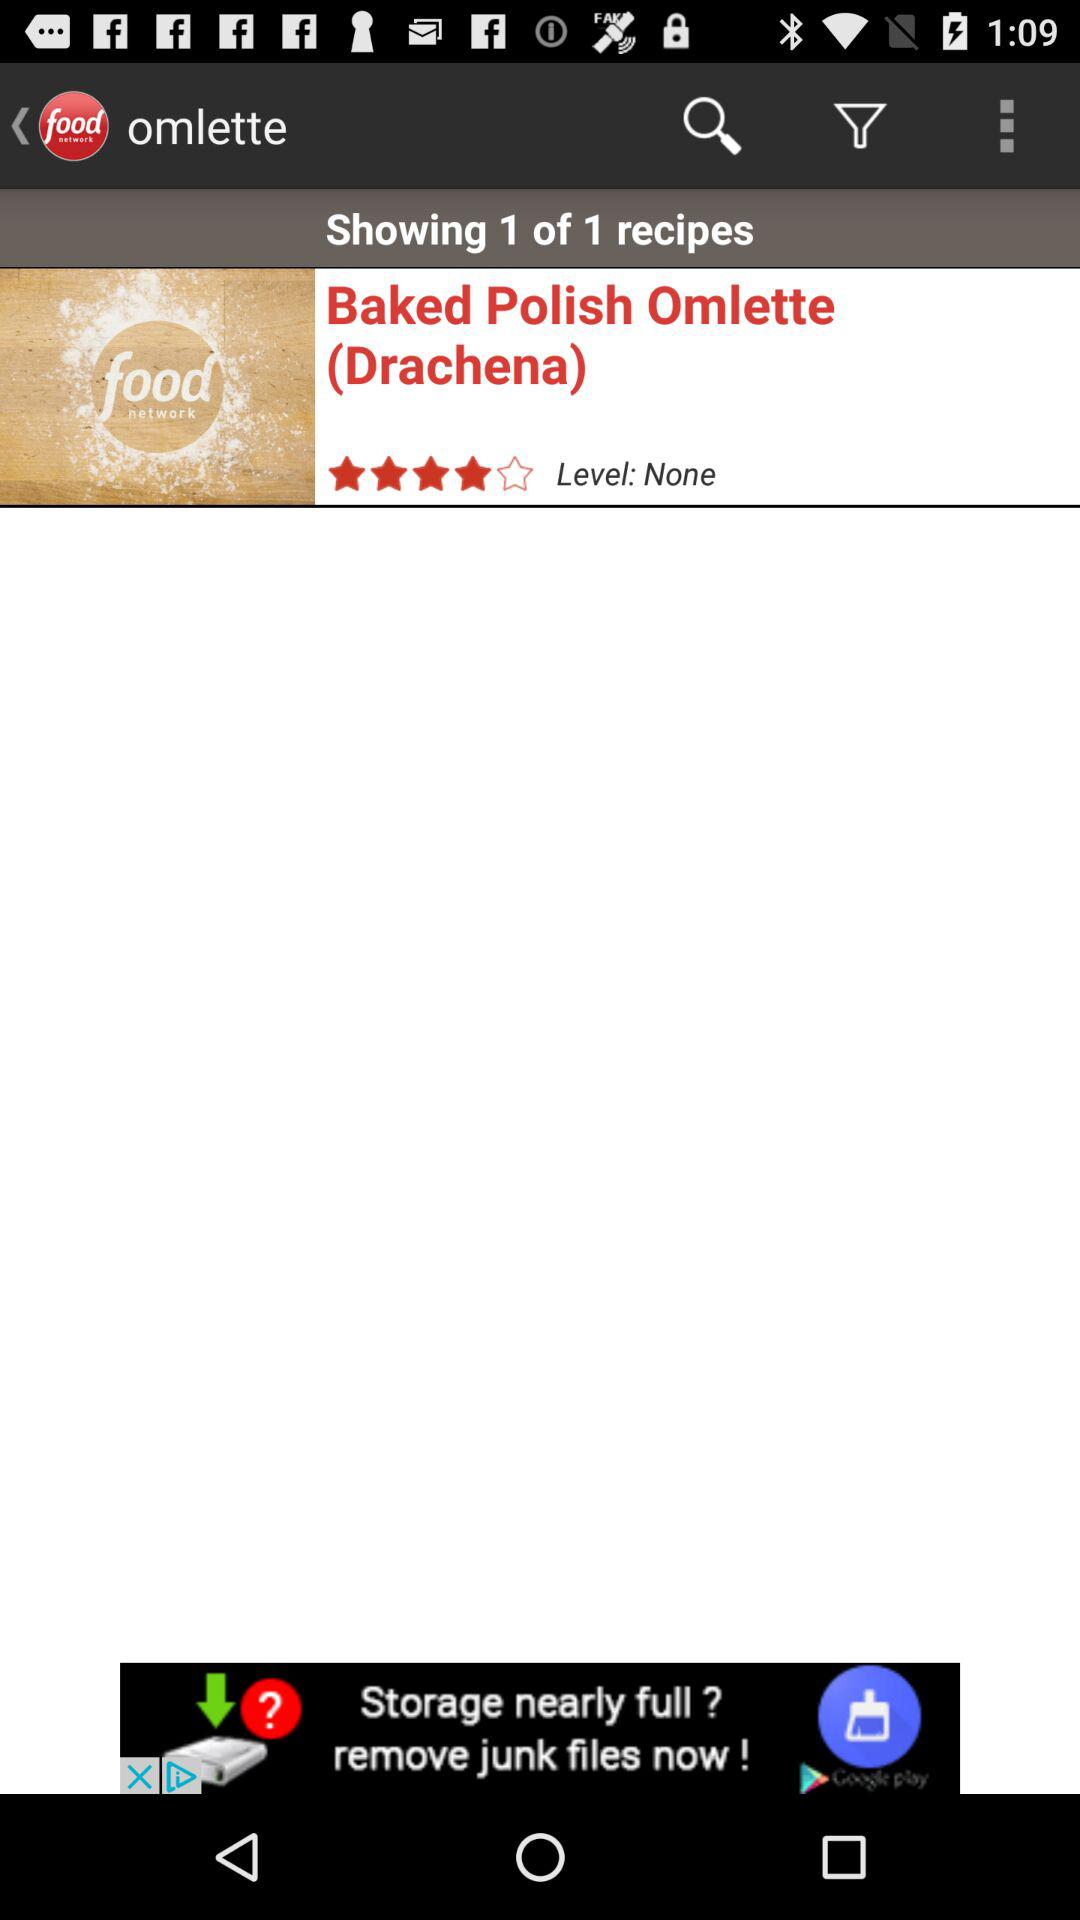How many stars are given to "Baked Polish Omlette"? There are four stars given to "Baked Polish Omlette". 